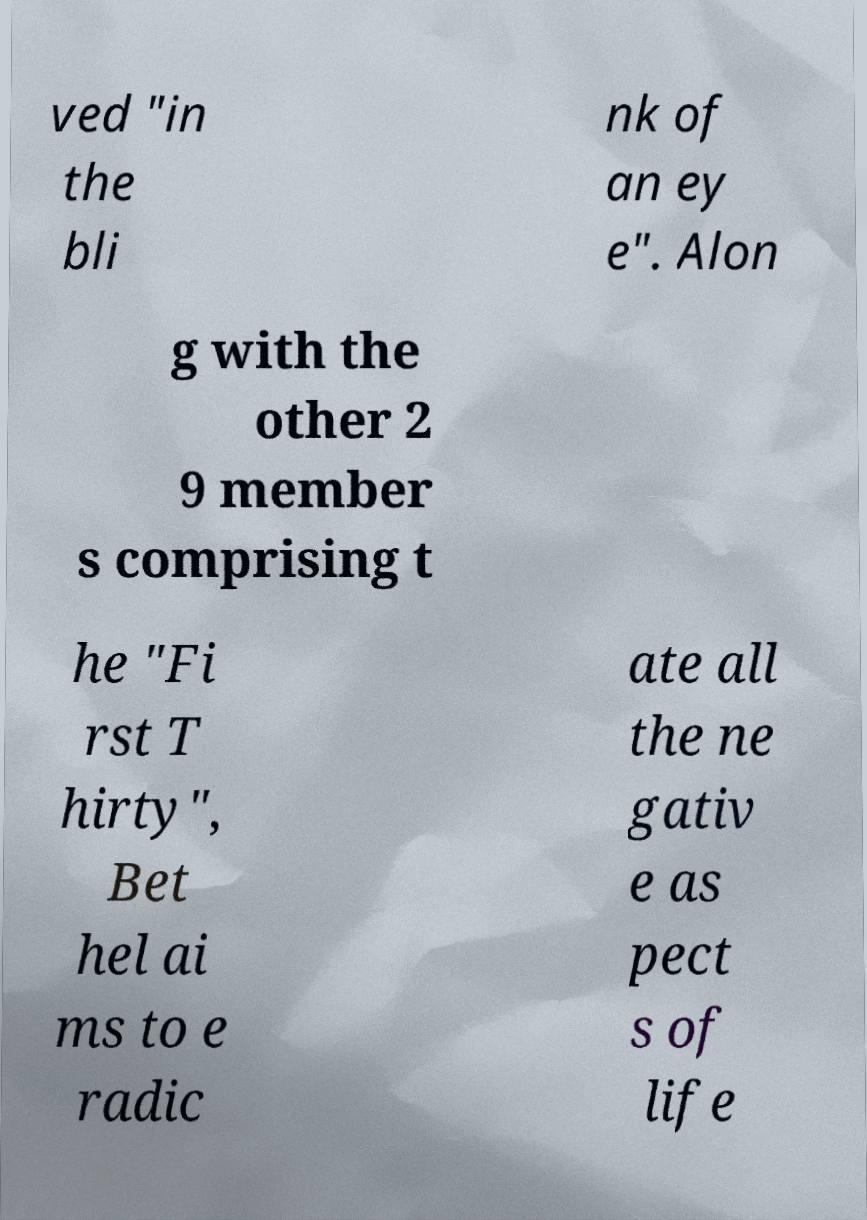Can you accurately transcribe the text from the provided image for me? ved "in the bli nk of an ey e". Alon g with the other 2 9 member s comprising t he "Fi rst T hirty", Bet hel ai ms to e radic ate all the ne gativ e as pect s of life 